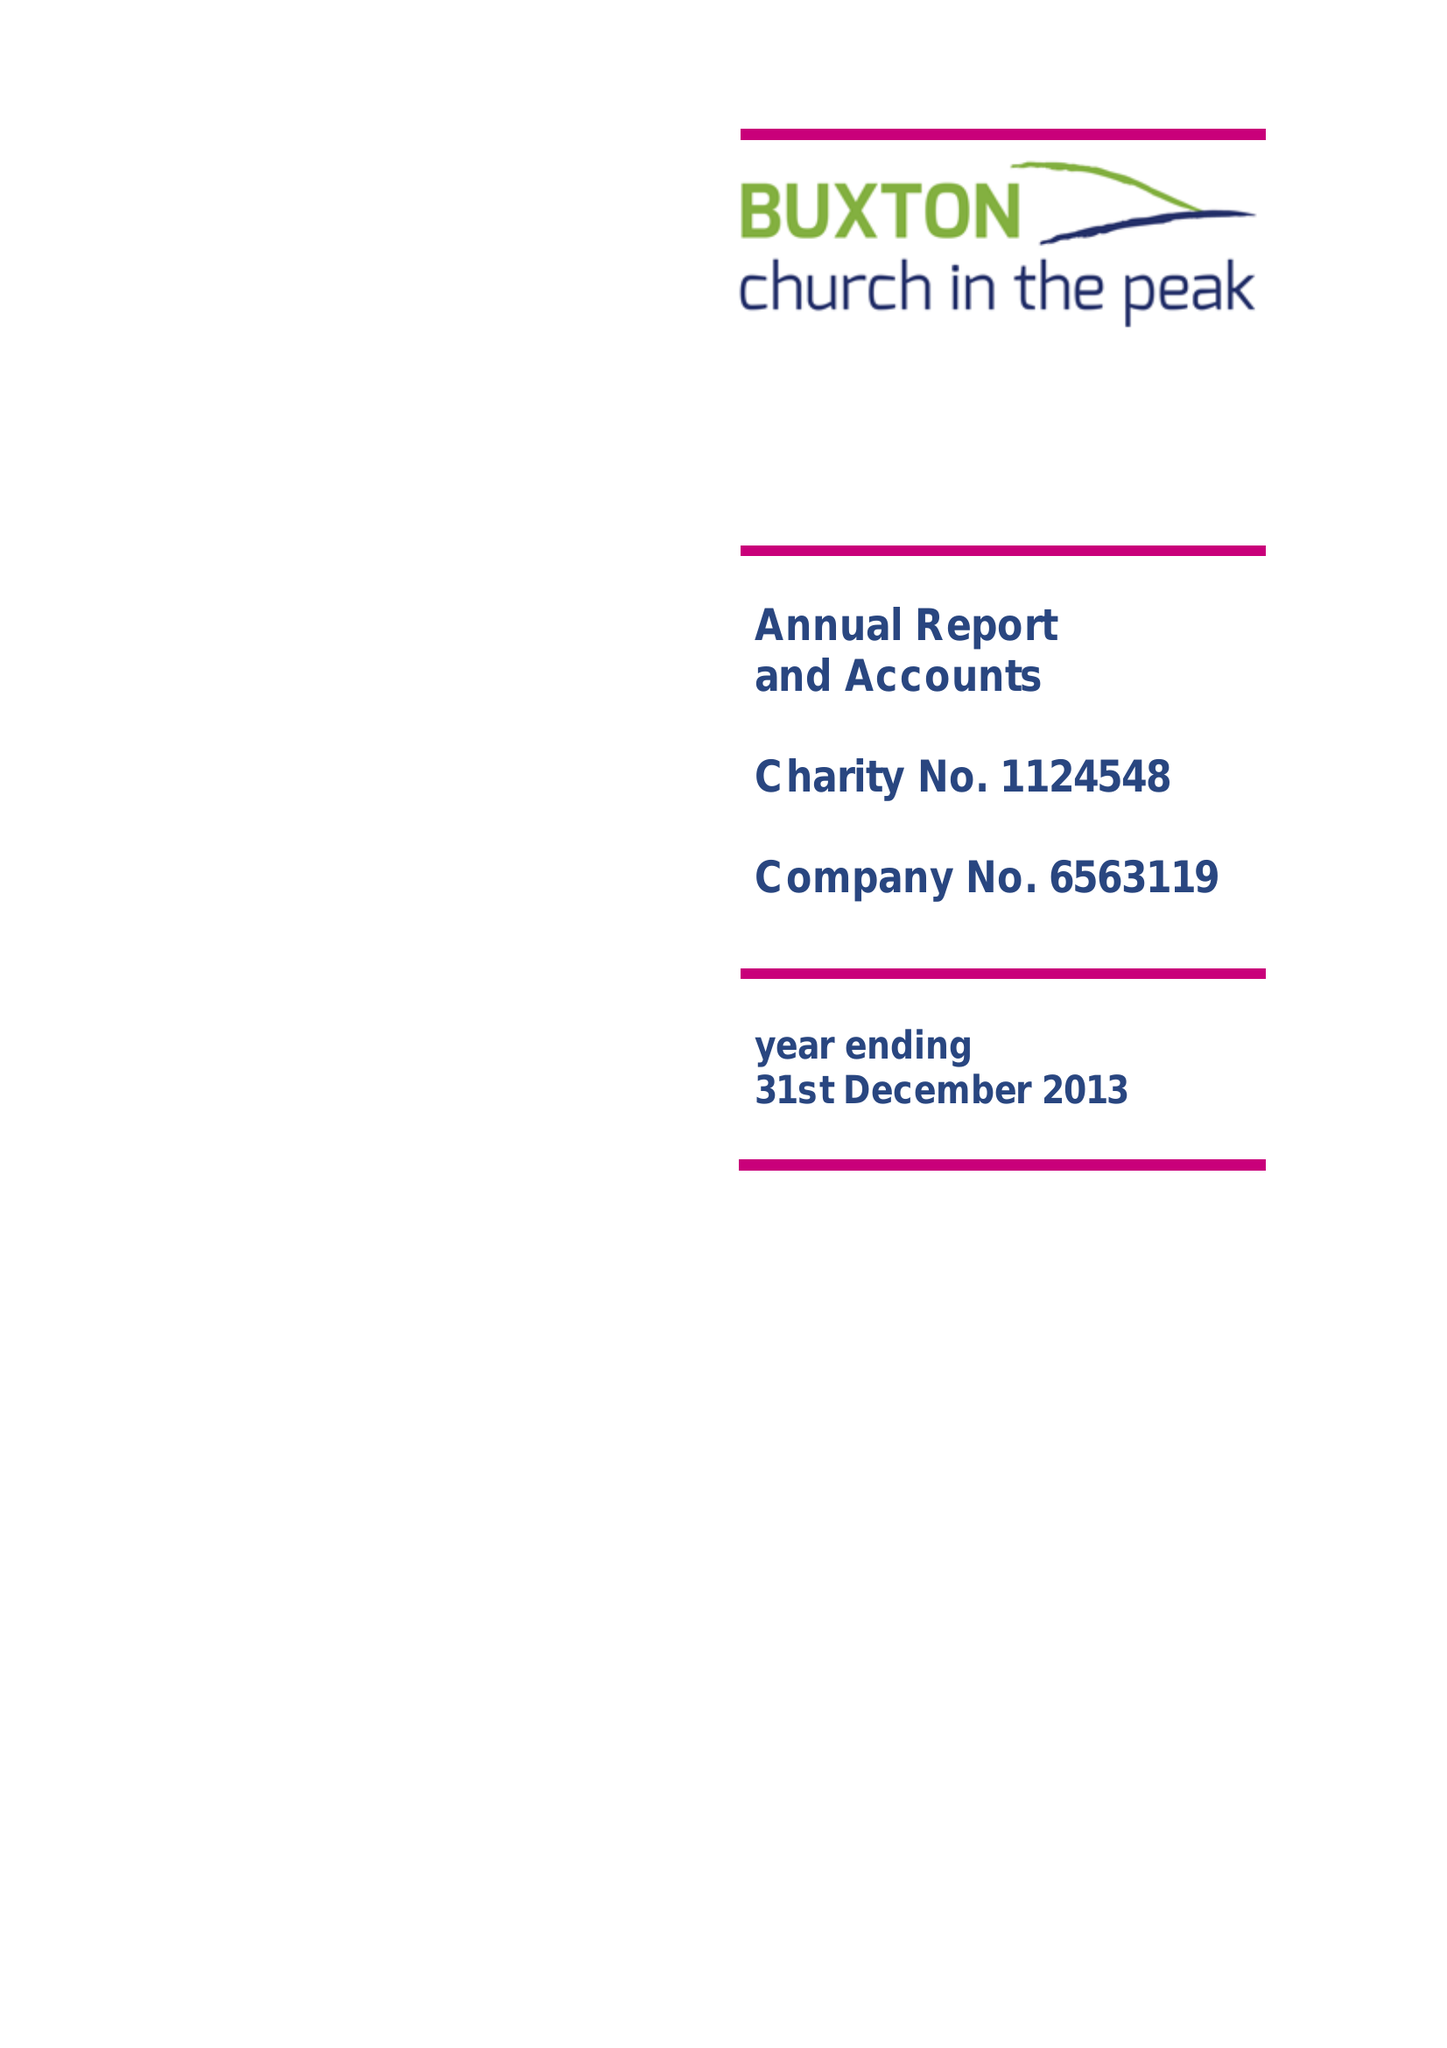What is the value for the report_date?
Answer the question using a single word or phrase. 2013-12-31 